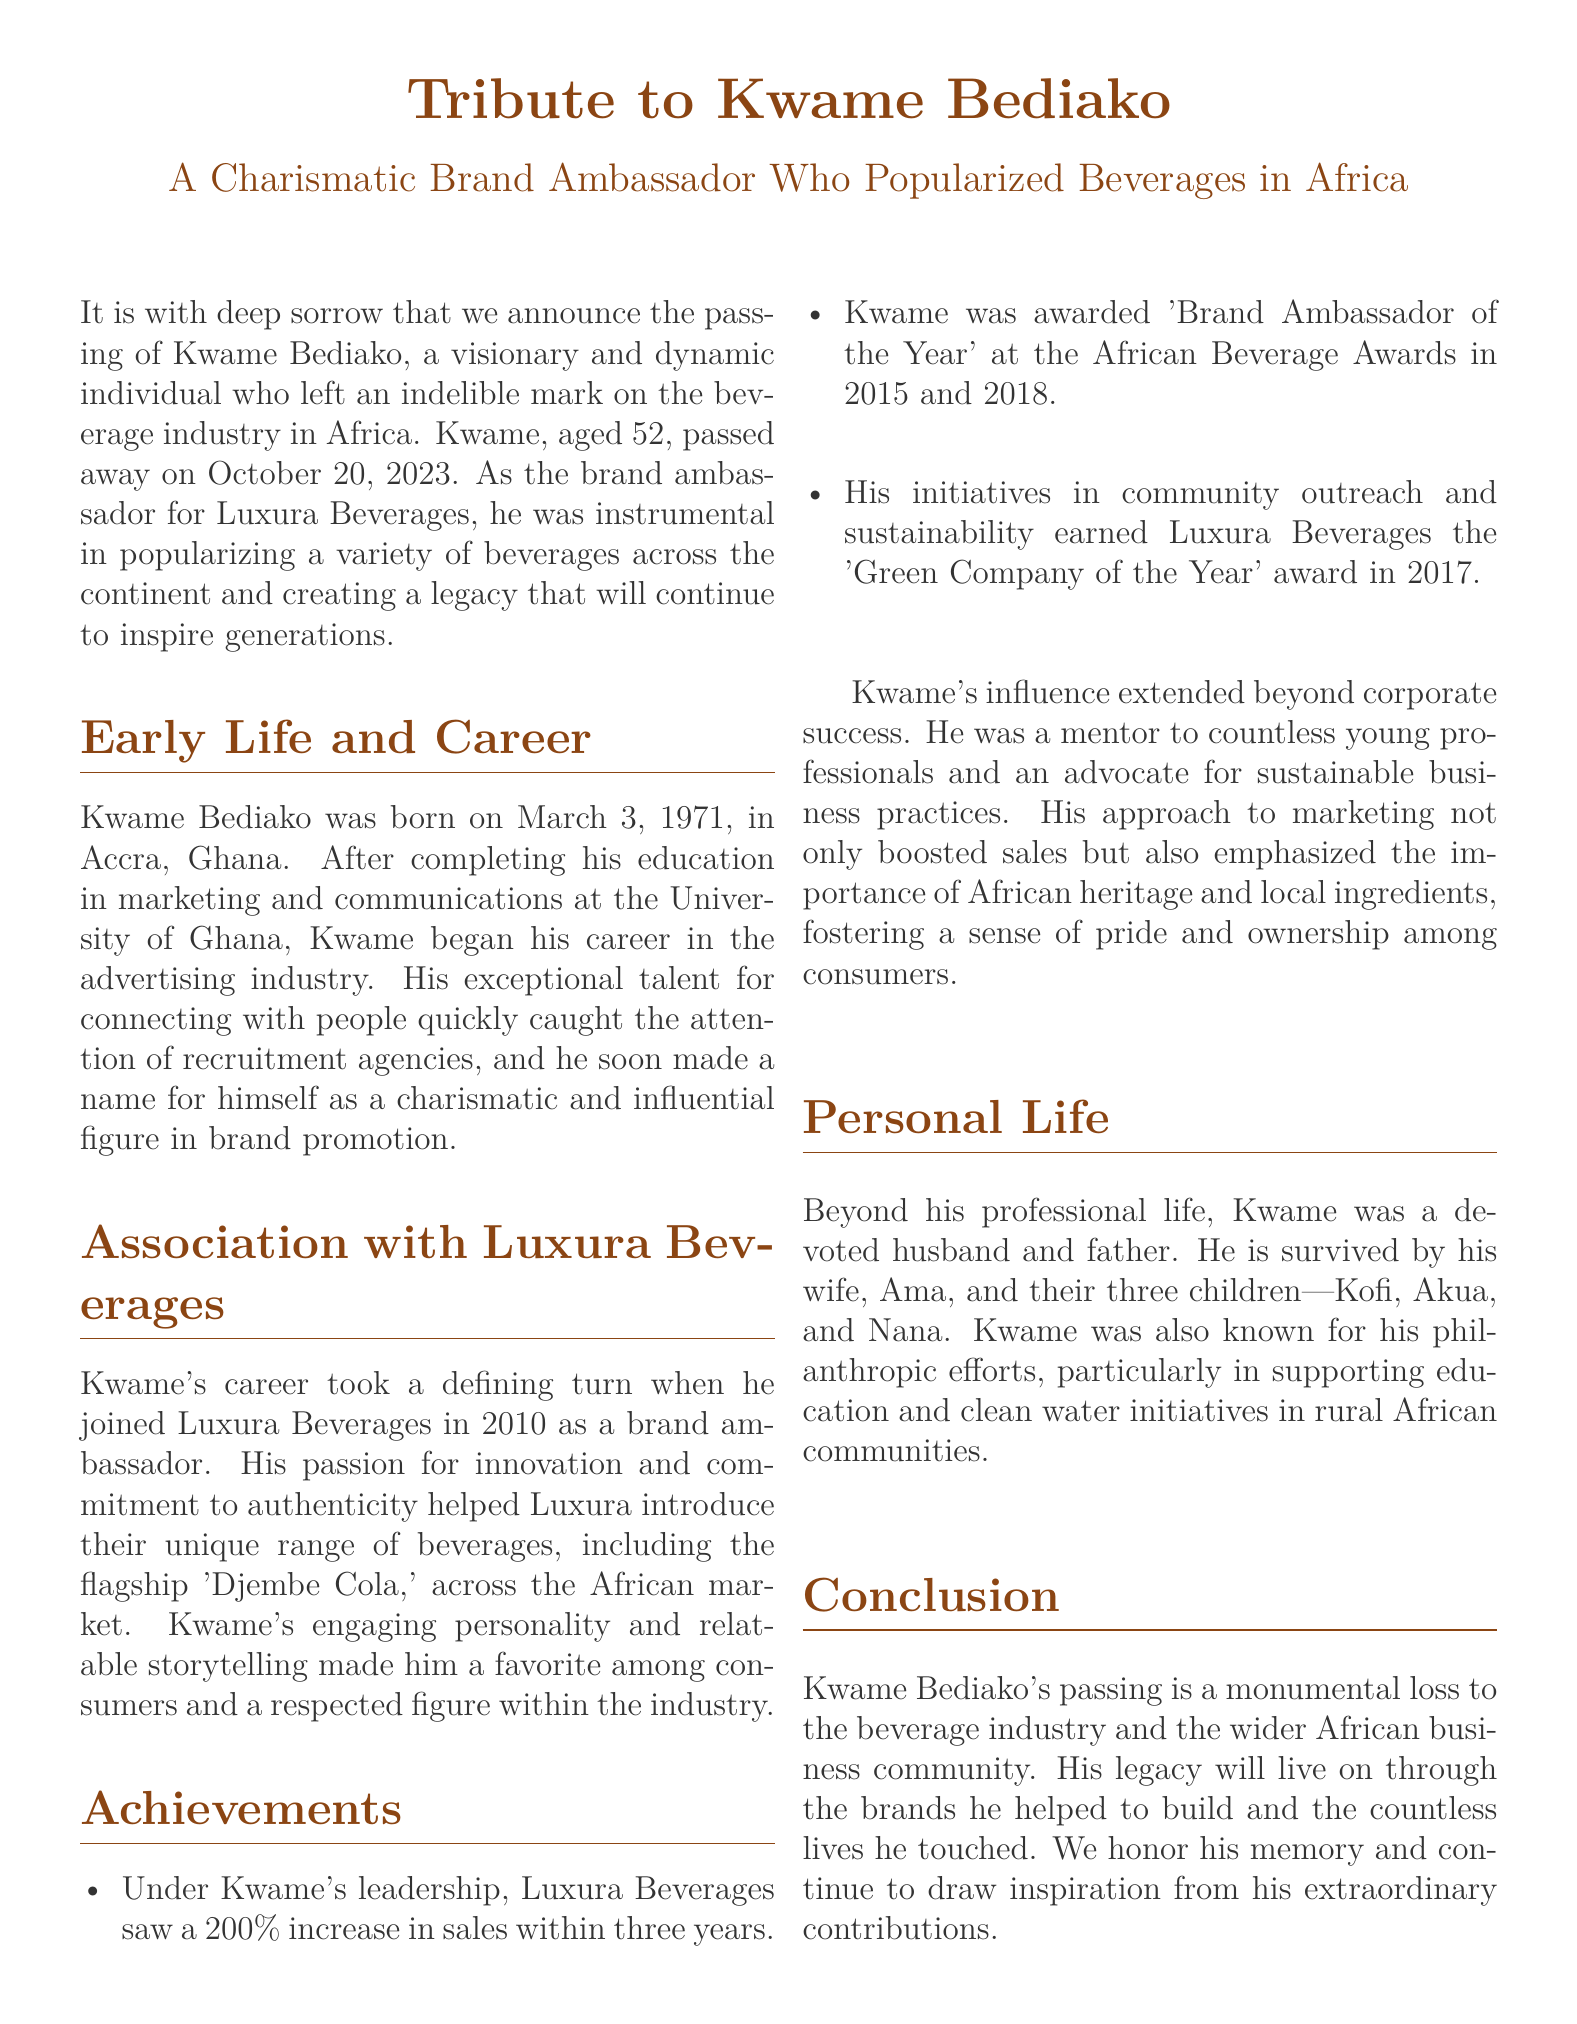What is the name of the brand ambassador? The document states that the brand ambassador is Kwame Bediako.
Answer: Kwame Bediako When was Kwame Bediako born? The document notes that Kwame Bediako was born on March 3, 1971.
Answer: March 3, 1971 Which beverage did Kwame help introduce? The document mentions that he helped introduce the flagship 'Djembe Cola.'
Answer: 'Djembe Cola' How many children did Kwame Bediako have? The document states that he is survived by three children.
Answer: three What award did he win in 2015? The document indicates he won 'Brand Ambassador of the Year' at the African Beverage Awards in 2015.
Answer: 'Brand Ambassador of the Year' What percentage increase in sales did Luxura Beverages see under Kwame's leadership? The document reports a 200% increase in sales.
Answer: 200% What year did Kwame pass away? The document states that Kwame Bediako passed away on October 20, 2023.
Answer: October 20, 2023 What were Kwame's contributions to sustainability recognized with in 2017? The document notes that his initiatives earned Luxura Beverages the 'Green Company of the Year' award.
Answer: 'Green Company of the Year' What was one of Kwame Bediako's philanthropic focuses? The document mentions his support for education and clean water initiatives in rural African communities.
Answer: education and clean water initiatives 